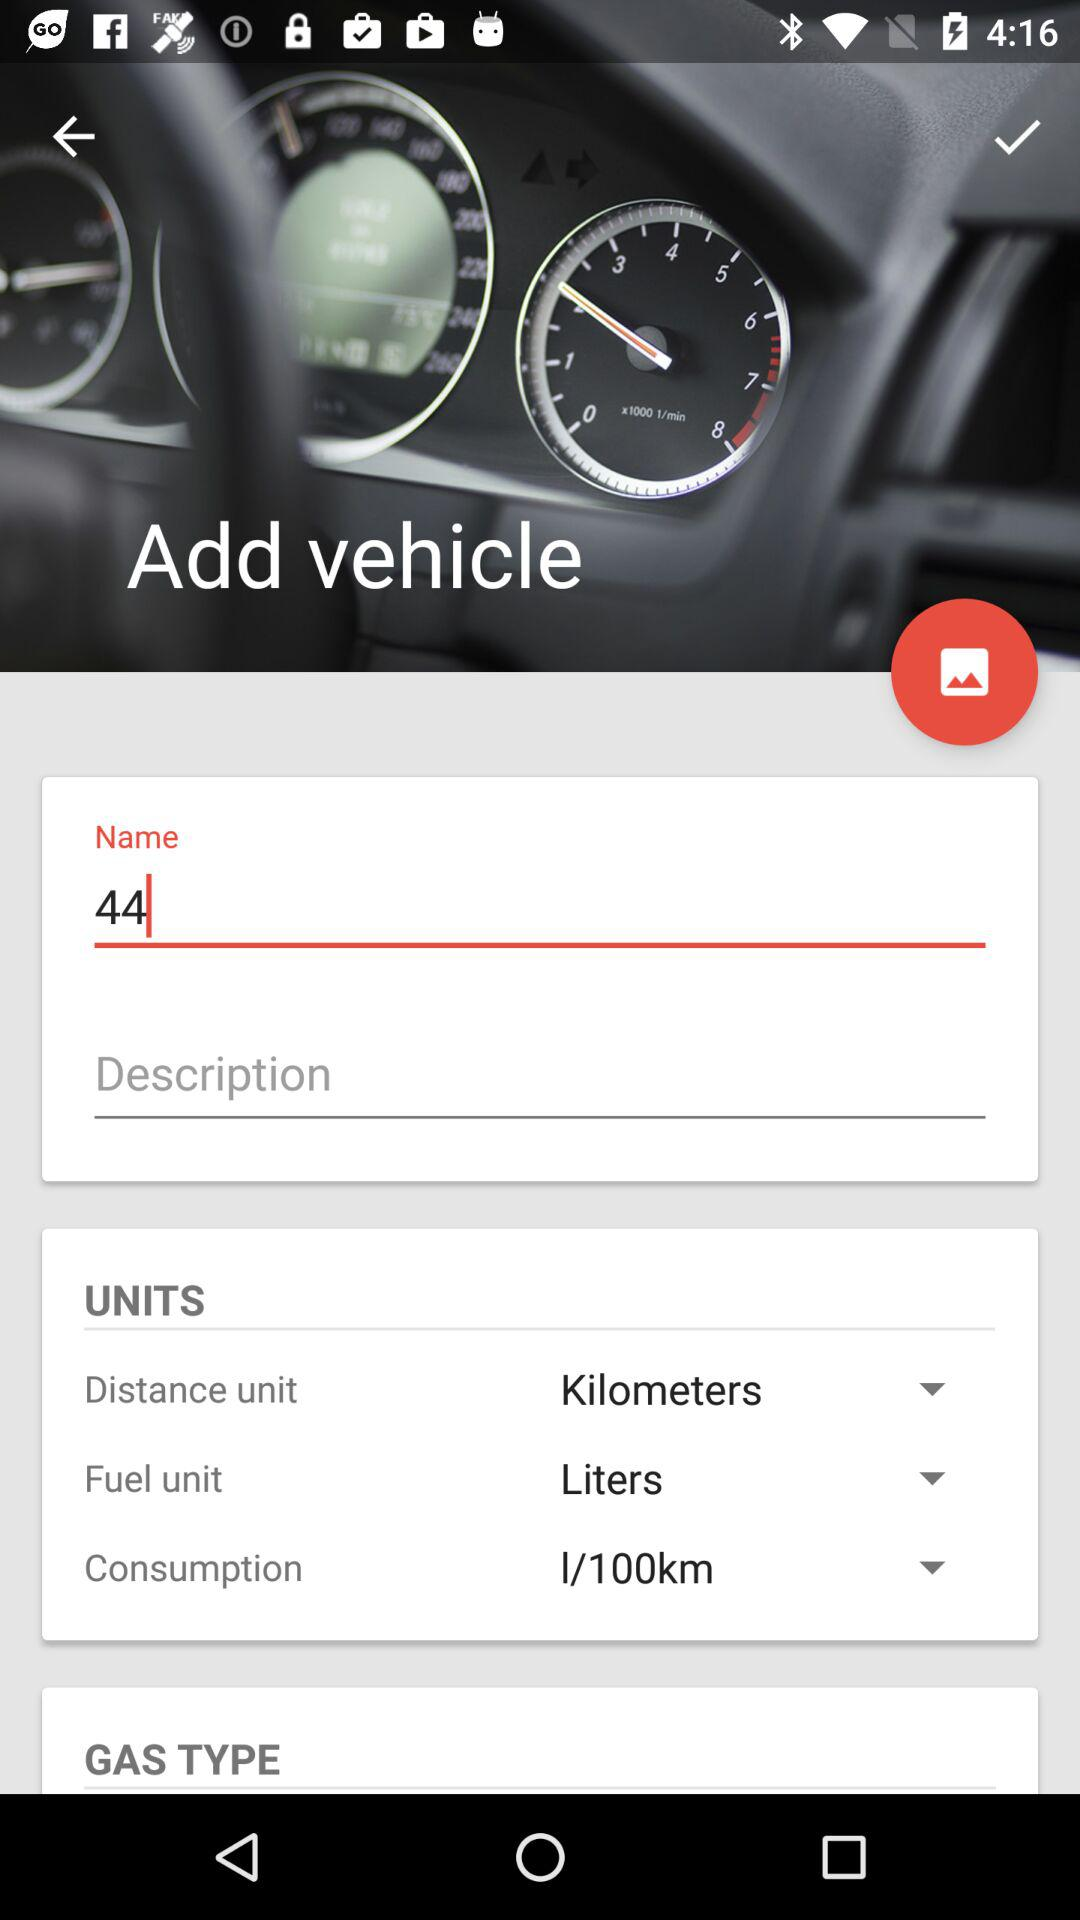What is the name of the vehicle? The name of the vehicle is 44. 